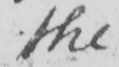What is written in this line of handwriting? the 